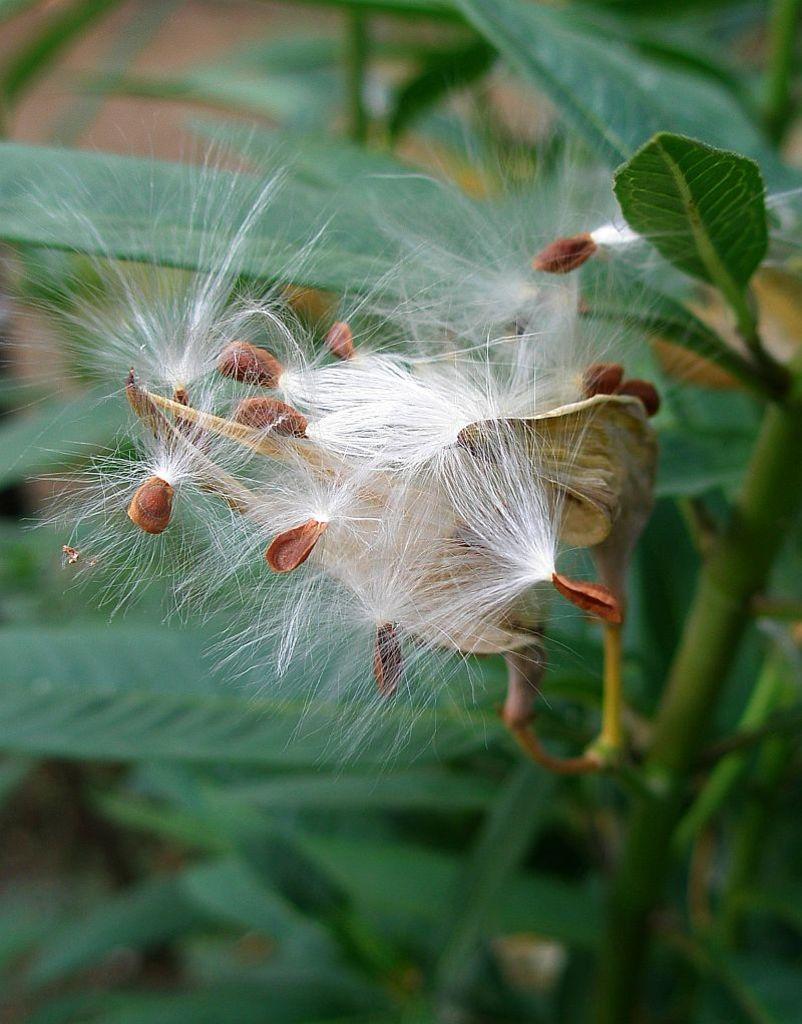In one or two sentences, can you explain what this image depicts? This is a zoomed in picture. In the center there is a white color object seems to be the flowers and buds and we can see the green leaves and stems of the plants. 